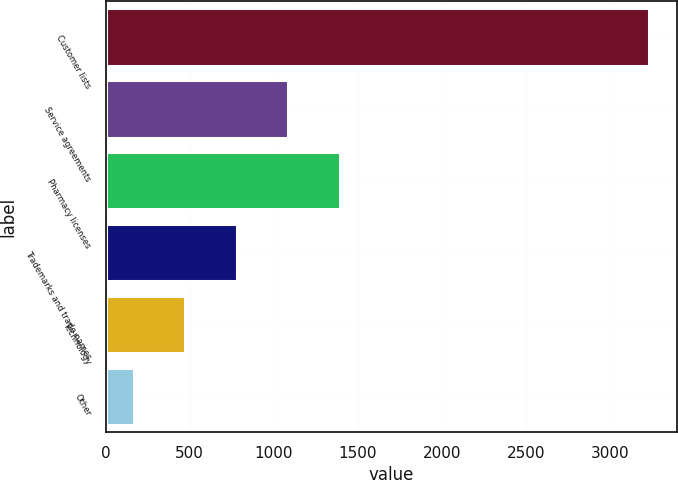Convert chart. <chart><loc_0><loc_0><loc_500><loc_500><bar_chart><fcel>Customer lists<fcel>Service agreements<fcel>Pharmacy licenses<fcel>Trademarks and trade names<fcel>Technology<fcel>Other<nl><fcel>3235<fcel>1086.7<fcel>1393.6<fcel>779.8<fcel>472.9<fcel>166<nl></chart> 